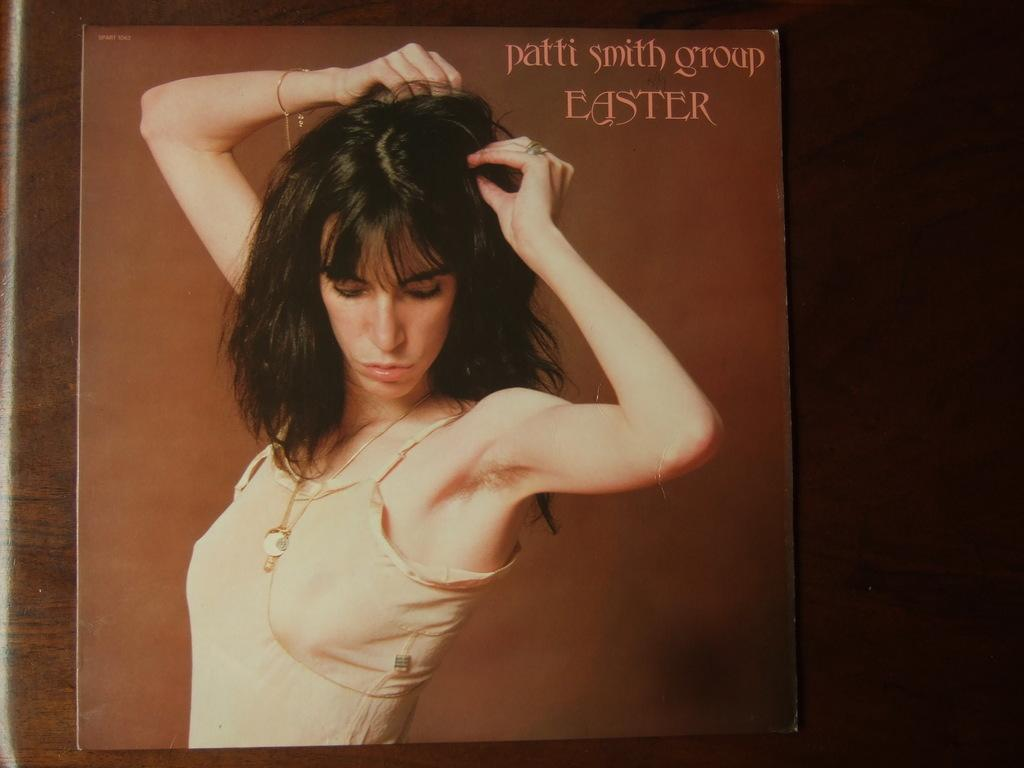What is on the wall in the image? There is a poster on the wall in the image. What is depicted on the poster? The poster features a woman. Are there any words on the poster? Yes, there is text on the poster. Can you see any flowers or plants in the garden shown on the poster? There is no garden or plants visible on the poster; it only features a woman and text. Is the woman on the poster crying or showing any emotions? The emotions of the woman on the poster cannot be determined from the image, as her facial expression is not visible. 